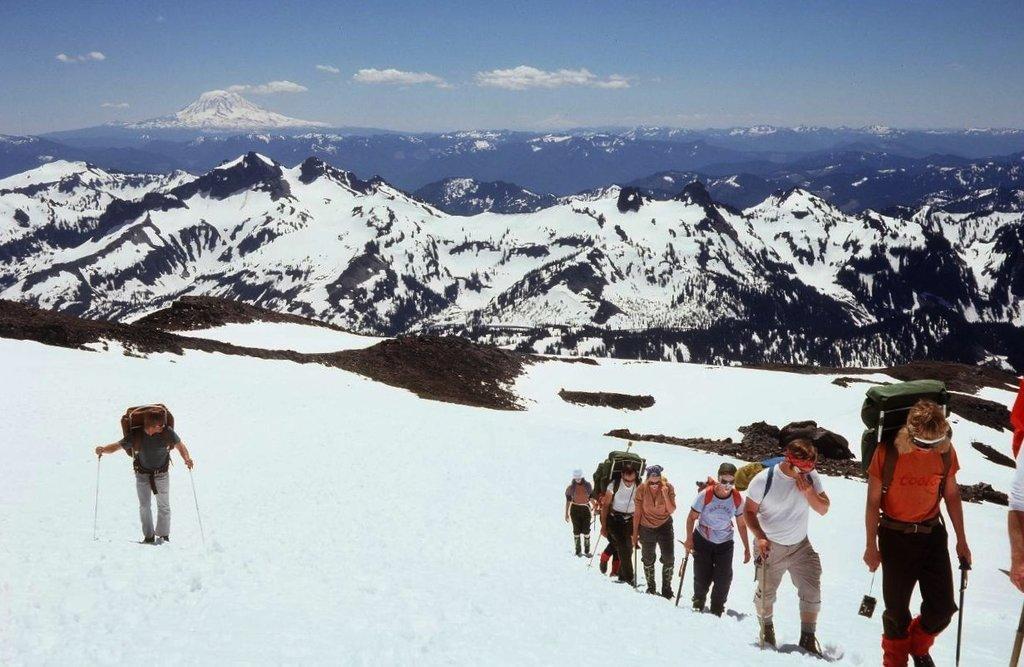Please provide a concise description of this image. In this image we can see the people wearing the bags and holding the sticks and climbing the mountain. We can also see the mountains and also the snow. We can see the sky with some clouds. 